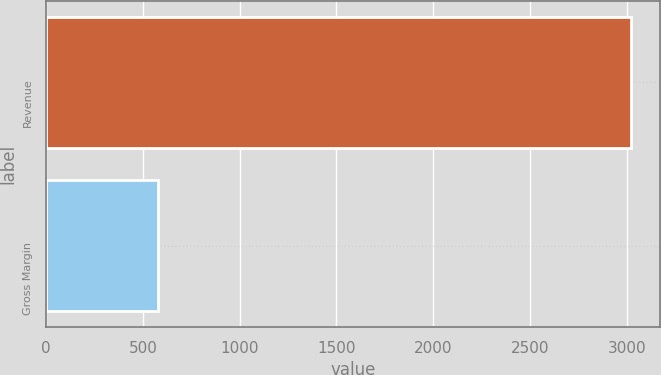Convert chart to OTSL. <chart><loc_0><loc_0><loc_500><loc_500><bar_chart><fcel>Revenue<fcel>Gross Margin<nl><fcel>3020<fcel>580<nl></chart> 